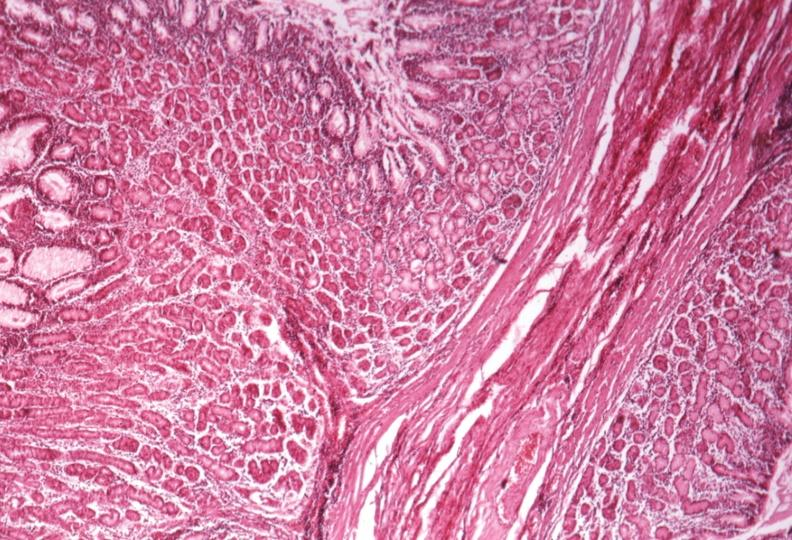where is this from?
Answer the question using a single word or phrase. Gastrointestinal system 